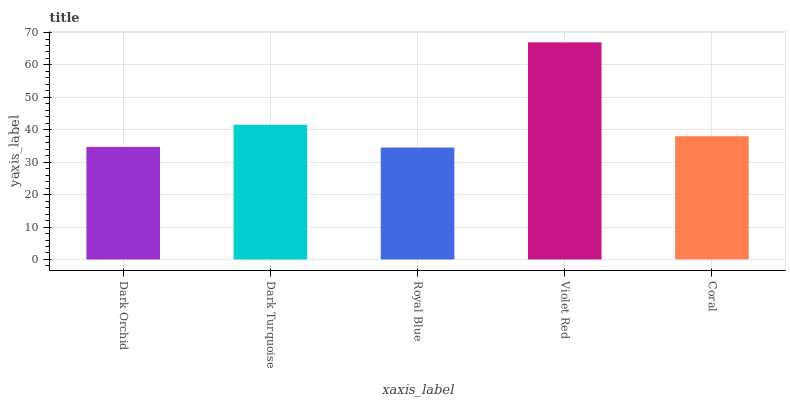Is Dark Turquoise the minimum?
Answer yes or no. No. Is Dark Turquoise the maximum?
Answer yes or no. No. Is Dark Turquoise greater than Dark Orchid?
Answer yes or no. Yes. Is Dark Orchid less than Dark Turquoise?
Answer yes or no. Yes. Is Dark Orchid greater than Dark Turquoise?
Answer yes or no. No. Is Dark Turquoise less than Dark Orchid?
Answer yes or no. No. Is Coral the high median?
Answer yes or no. Yes. Is Coral the low median?
Answer yes or no. Yes. Is Royal Blue the high median?
Answer yes or no. No. Is Dark Turquoise the low median?
Answer yes or no. No. 